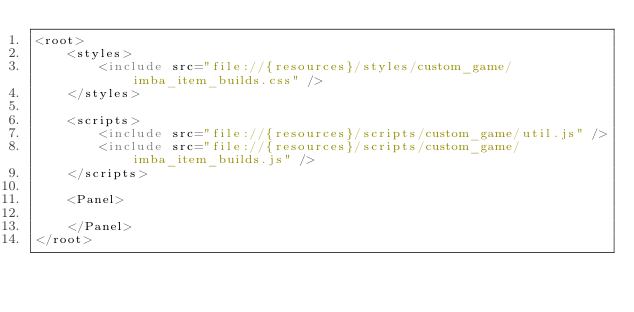<code> <loc_0><loc_0><loc_500><loc_500><_XML_><root>
	<styles>
		<include src="file://{resources}/styles/custom_game/imba_item_builds.css" />
	</styles>

	<scripts>
		<include src="file://{resources}/scripts/custom_game/util.js" />
		<include src="file://{resources}/scripts/custom_game/imba_item_builds.js" />
	</scripts>

	<Panel>

	</Panel>
</root>
</code> 